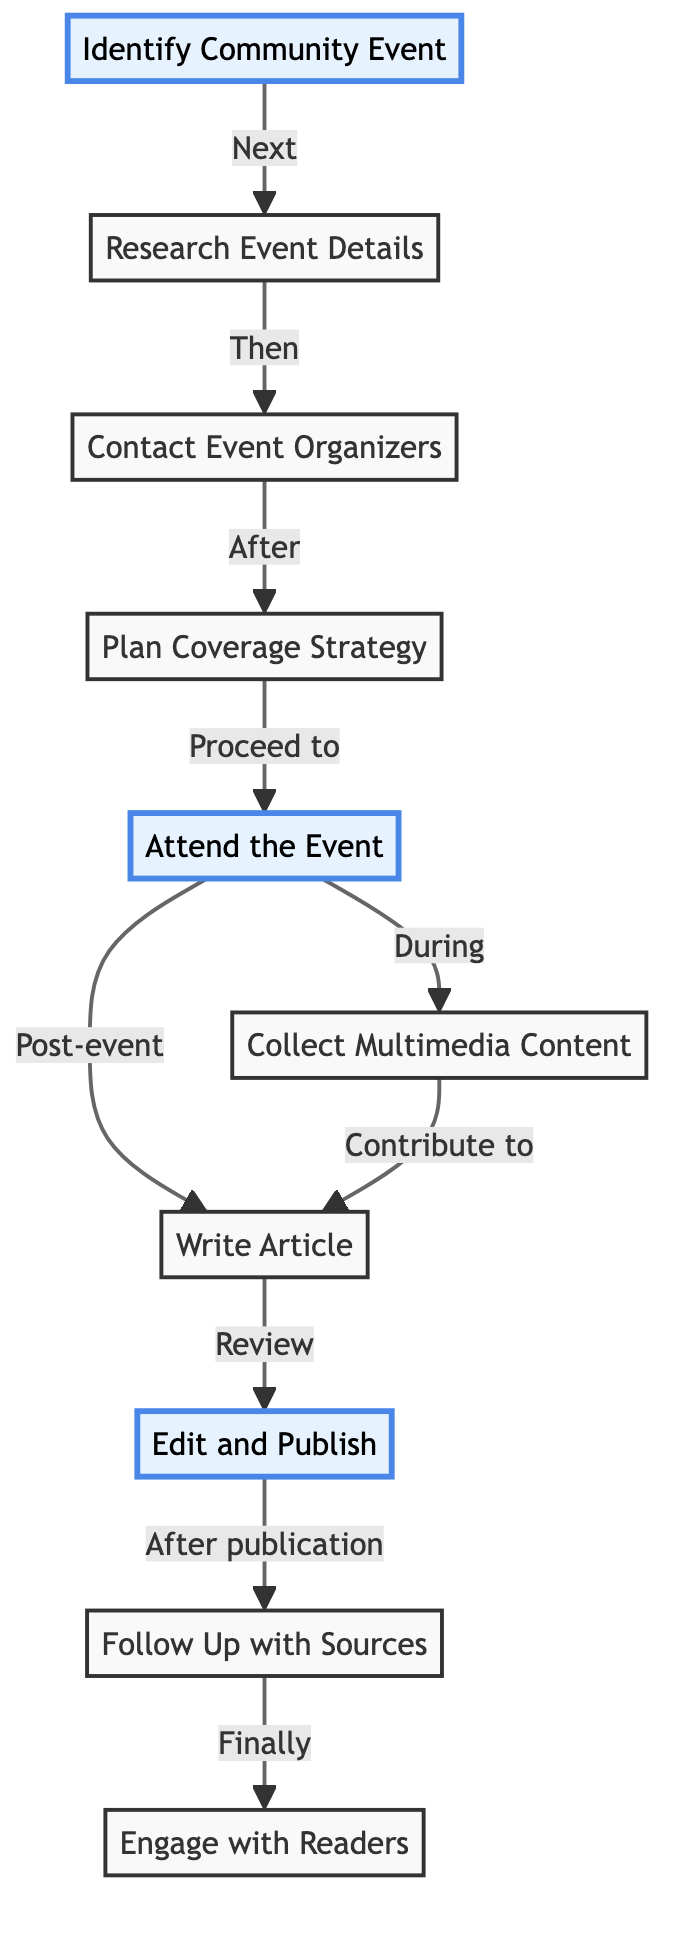What is the first step in the flow of events? According to the diagram, the first step is "Identify Community Event." This is indicated as the initial node in the flow.
Answer: Identify Community Event How many nodes are there in the flowchart? By counting the elements listed, there are 10 distinct nodes in the flowchart, each representing a different step in the event coverage process.
Answer: 10 What step follows "Research Event Details"? The diagram shows that the step that follows "Research Event Details" is "Contact Event Organizers." This is indicated by the arrow leading from the second node to the third.
Answer: Contact Event Organizers What activities occur during the event? The diagram specifies that during the event, the activities "Attend the Event" and "Collect Multimedia Content" are both indicated. This means the journalist participates in the event and captures content simultaneously.
Answer: Attend the Event, Collect Multimedia Content What is the final step after publishing the article? The final step in the diagram is "Engage with Readers," which is linked to "Follow Up with Sources" to illustrate the concluding phase of the event coverage.
Answer: Engage with Readers How does "Write Article" relate to "Collect Multimedia Content"? In the flowchart, "Write Article" is connected to "Collect Multimedia Content" through the phrase "Contribute to." This indicates that the multimedia content gathered aids in the article writing process.
Answer: Contribute to Which steps are highlighted in the diagram? The steps highlighted in the diagram are "Identify Community Event," "Attend the Event," and "Edit and Publish." These are emphasized to showcase their importance in the coverage process.
Answer: Identify Community Event, Attend the Event, Edit and Publish What comes after "Attend the Event"? After "Attend the Event," the next step is "Write Article," indicating that after being present at the event, the journalist moves on to writing about it.
Answer: Write Article 